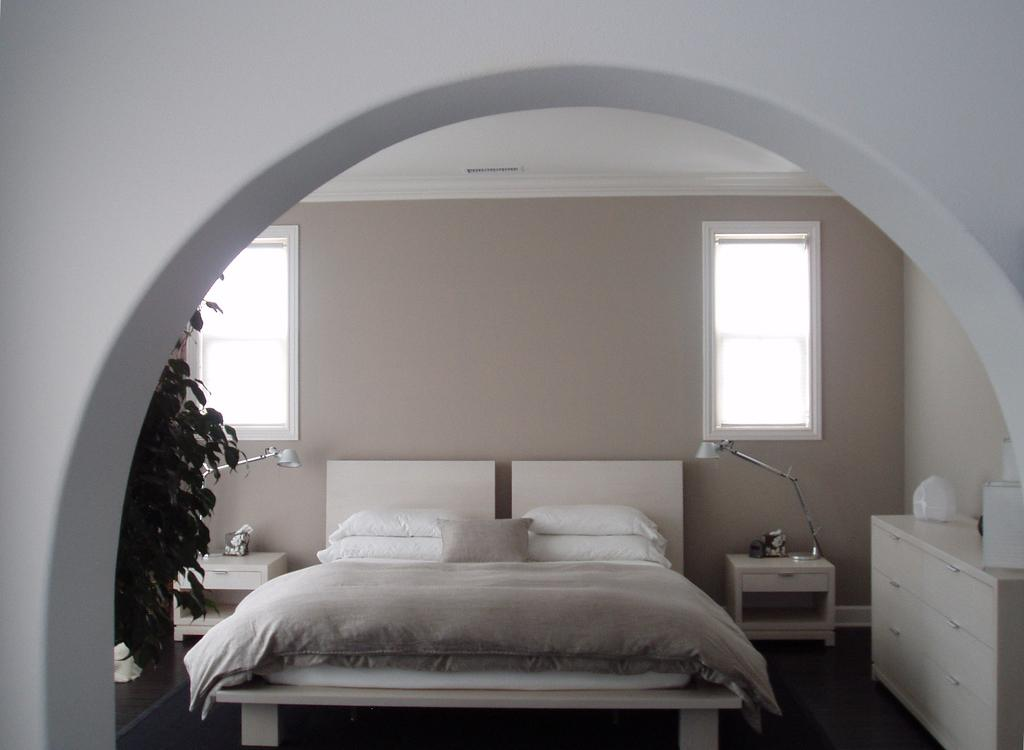What type of furniture is present in the image? There is a bed and a table on the floor in the image. What is on the bed in the image? The bed has pillows on it. What type of vegetation is visible in the image? There is a plant in the image. What is the background of the image made of? There is a wall in the image. How does the plant use the brake to slow down its growth in the image? The plant does not use a brake to slow down its growth in the image, as plants do not have brakes. 